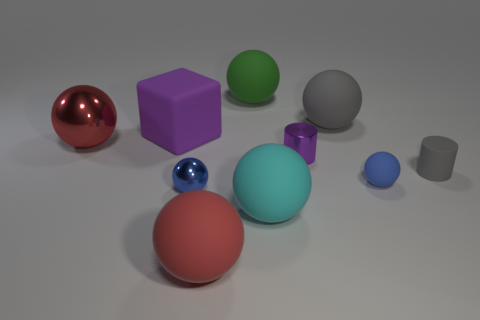Is the size of the purple thing that is behind the large red metallic thing the same as the green rubber thing that is behind the big purple matte block?
Provide a succinct answer. Yes. How many objects are tiny blue metal objects or purple metal cylinders on the right side of the big red metal thing?
Keep it short and to the point. 2. How big is the gray object in front of the purple rubber cube?
Provide a succinct answer. Small. Are there fewer small gray matte cylinders on the left side of the large cube than big cubes on the right side of the blue shiny object?
Provide a succinct answer. No. There is a large sphere that is left of the cyan object and in front of the gray cylinder; what is it made of?
Make the answer very short. Rubber. The large red thing to the right of the red thing that is to the left of the purple cube is what shape?
Your answer should be compact. Sphere. Do the metallic cylinder and the tiny matte cylinder have the same color?
Provide a succinct answer. No. How many red things are either large blocks or matte spheres?
Offer a very short reply. 1. Are there any tiny gray matte things on the left side of the large purple matte thing?
Your answer should be compact. No. The blue rubber thing has what size?
Make the answer very short. Small. 